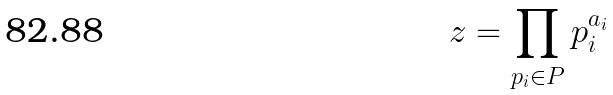Convert formula to latex. <formula><loc_0><loc_0><loc_500><loc_500>z = \prod _ { p _ { i } \in P } p _ { i } ^ { a _ { i } }</formula> 